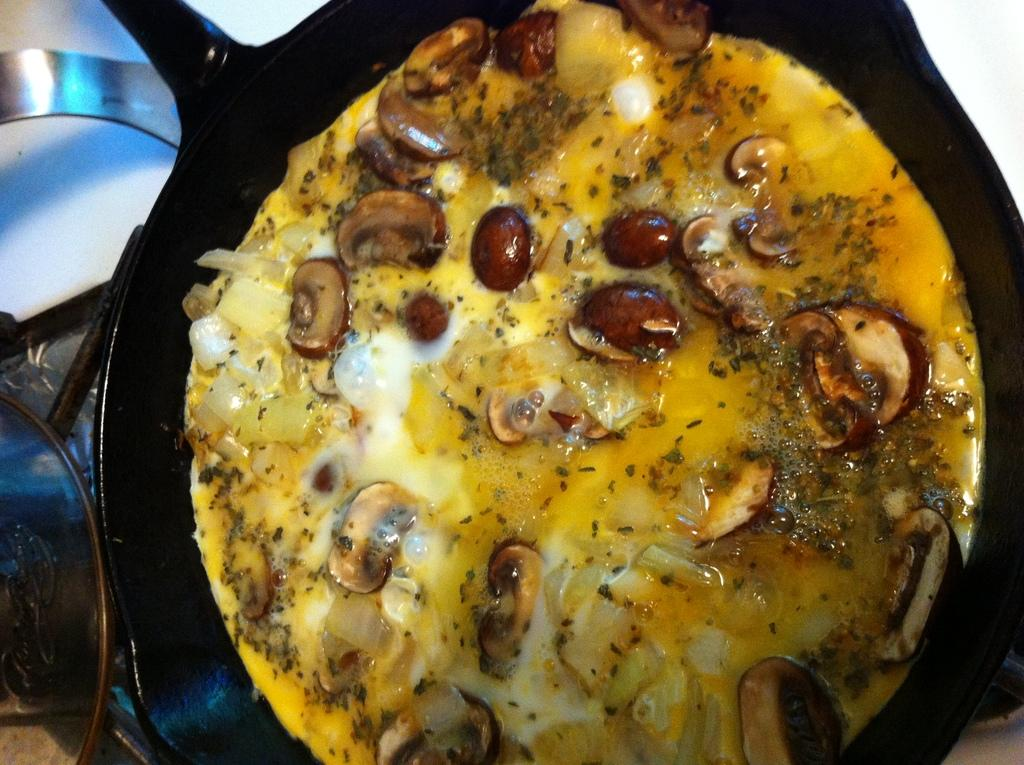What color is the object containing the food items in the image? The object containing the food items is black. What can be seen in the background of the image? There are other objects visible in the background of the image. Are there any jellyfish visible in the image? No, there are no jellyfish present in the image. 